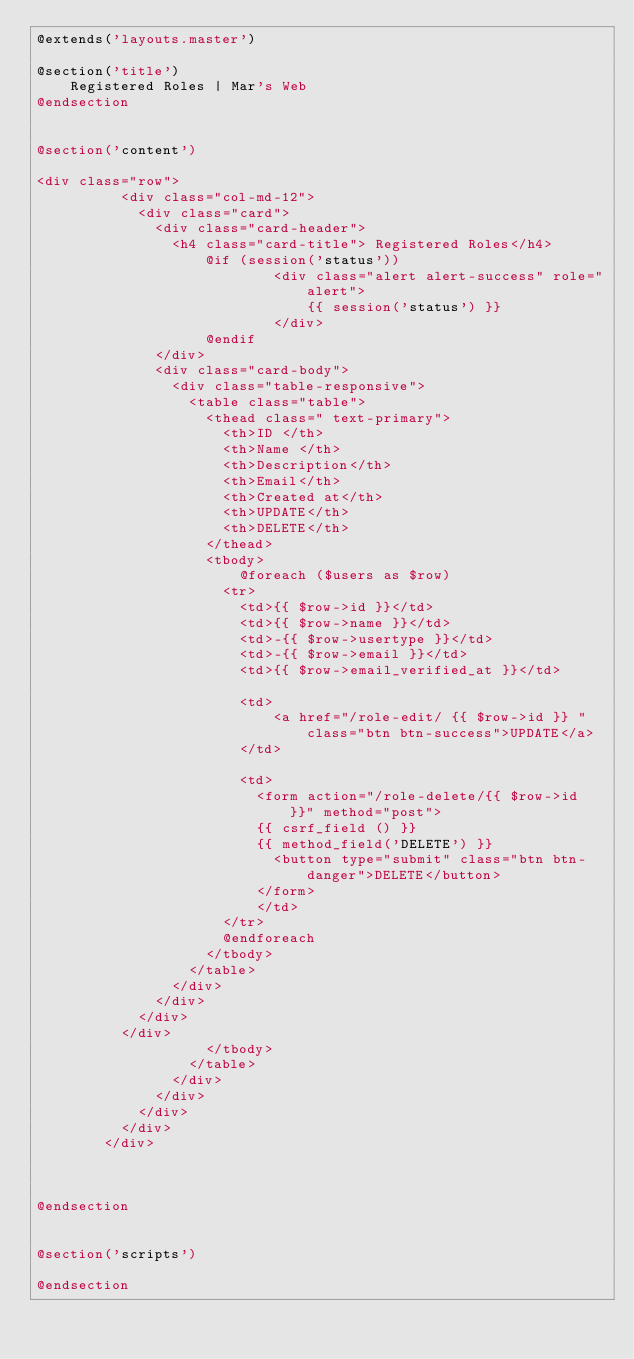Convert code to text. <code><loc_0><loc_0><loc_500><loc_500><_PHP_>@extends('layouts.master')

@section('title')
    Registered Roles | Mar's Web
@endsection


@section('content')

<div class="row">
          <div class="col-md-12">
            <div class="card">
              <div class="card-header">
                <h4 class="card-title"> Registered Roles</h4>
                    @if (session('status'))
                            <div class="alert alert-success" role="alert">
                                {{ session('status') }}
                            </div>
                    @endif
              </div>
              <div class="card-body">
                <div class="table-responsive">
                  <table class="table">
                    <thead class=" text-primary">
                      <th>ID </th>
                      <th>Name </th>
                      <th>Description</th>
                      <th>Email</th>
                      <th>Created at</th>
                      <th>UPDATE</th>
                      <th>DELETE</th>
                    </thead>
                    <tbody>
                        @foreach ($users as $row)
                      <tr>
                        <td>{{ $row->id }}</td>
                        <td>{{ $row->name }}</td>
                        <td>-{{ $row->usertype }}</td>
                        <td>-{{ $row->email }}</td>
                        <td>{{ $row->email_verified_at }}</td>
                        
                        <td>
                            <a href="/role-edit/ {{ $row->id }} " class="btn btn-success">UPDATE</a>
                        </td>

                        <td>
                          <form action="/role-delete/{{ $row->id }}" method="post">
                          {{ csrf_field () }} 
                          {{ method_field('DELETE') }} 
                            <button type="submit" class="btn btn-danger">DELETE</button>
                          </form>
                          </td>
                      </tr>
                      @endforeach
                    </tbody>
                  </table>
                </div>
              </div>
            </div>
          </div>
                    </tbody>
                  </table>
                </div>
              </div>
            </div>
          </div>
        </div>



@endsection


@section('scripts')

@endsection</code> 